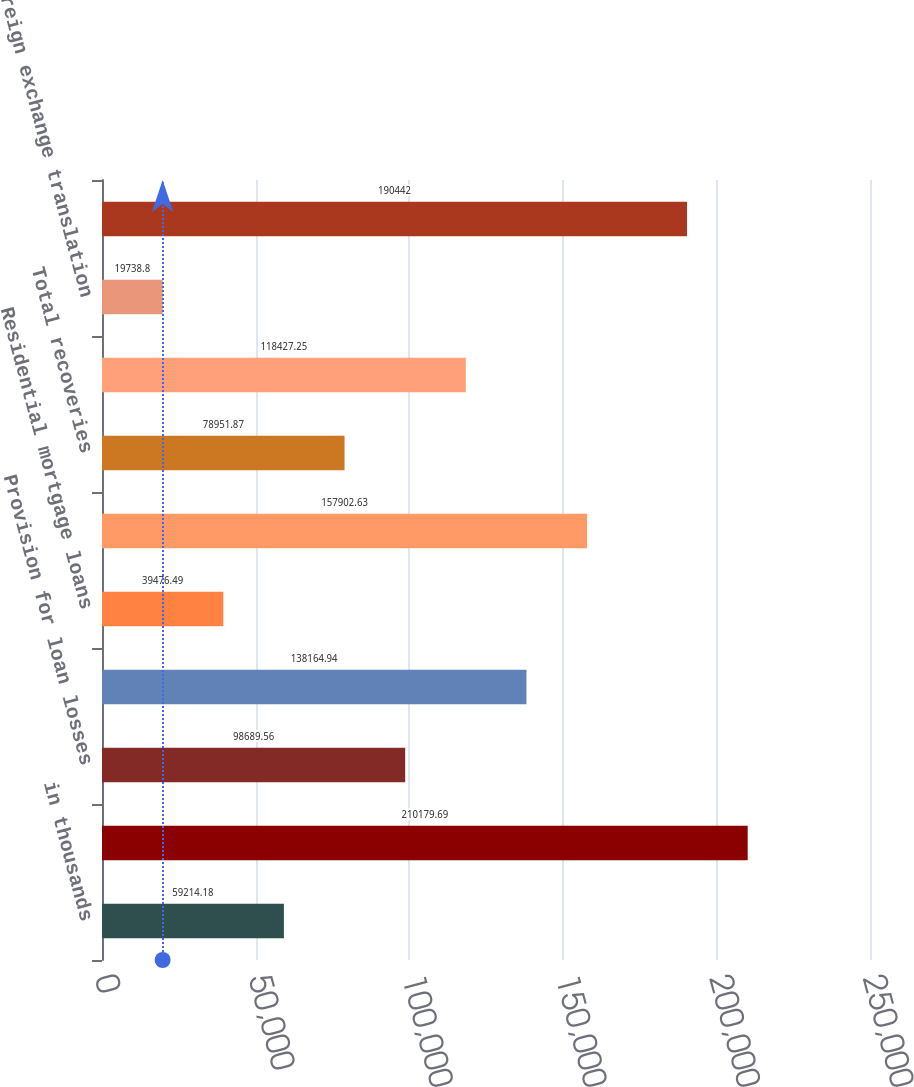Convert chart to OTSL. <chart><loc_0><loc_0><loc_500><loc_500><bar_chart><fcel>in thousands<fcel>Allowance for loan losses<fcel>Provision for loan losses<fcel>C&I loans<fcel>Residential mortgage loans<fcel>Total charge-offs<fcel>Total recoveries<fcel>Net (charge-offs)/recoveries<fcel>Foreign exchange translation<fcel>Allowance for loan losses end<nl><fcel>59214.2<fcel>210180<fcel>98689.6<fcel>138165<fcel>39476.5<fcel>157903<fcel>78951.9<fcel>118427<fcel>19738.8<fcel>190442<nl></chart> 